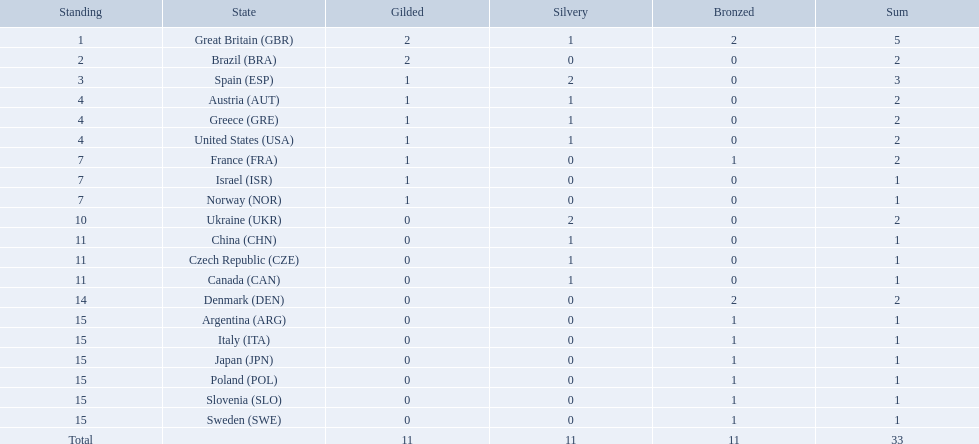Which nation received 2 silver medals? Spain (ESP), Ukraine (UKR). Of those, which nation also had 2 total medals? Spain (ESP). How many medals did spain gain 3. Only country that got more medals? Spain (ESP). 